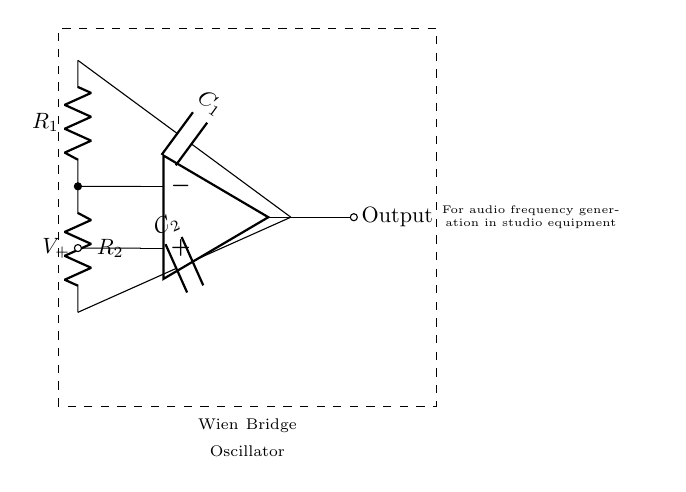What type of oscillator is shown in the circuit? The circuit diagram depicts a Wien bridge oscillator, which is identifiable from the specific configuration of resistors and capacitors used for generating audio frequencies, commonly employed in audio equipment.
Answer: Wien bridge oscillator What are the two types of components used in this circuit? The circuit contains resistors and capacitors, as indicated by the labels R1, R2, C1, and C2 within the diagram. The presence of these components is fundamental to the functioning of the oscillator.
Answer: Resistors and capacitors How many resistors are present in the circuit? The circuit includes two resistors, labeled R1 and R2, shown as distinct components connected between the inverting input of the operational amplifier and the capacitors.
Answer: Two What is the role of the operational amplifier in this circuit? The operational amplifier serves as a vital component for amplifying the voltage across the circuit, enabling oscillation through feedback, which is essential in maintaining the oscillation frequency.
Answer: Amplification What happens if one of the resistors is changed to a higher value? Increasing the value of one resistor affects the gain of the operational amplifier circuit, potentially leading to a change in the oscillation frequency, as the Wien bridge oscillator relies on precise resistor and capacitor ratios to determine frequency.
Answer: Frequency increases What is the expected output of this circuit? The output of the Wien bridge oscillator is a sinusoidal waveform, indicating the generated audio frequency. This waveform is typically used in studio equipment as a reference signal or for testing.
Answer: Sinusoidal waveform 